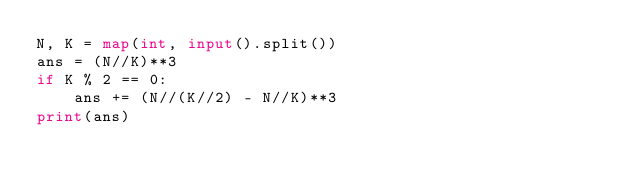<code> <loc_0><loc_0><loc_500><loc_500><_Python_>N, K = map(int, input().split())
ans = (N//K)**3
if K % 2 == 0:
    ans += (N//(K//2) - N//K)**3
print(ans)</code> 